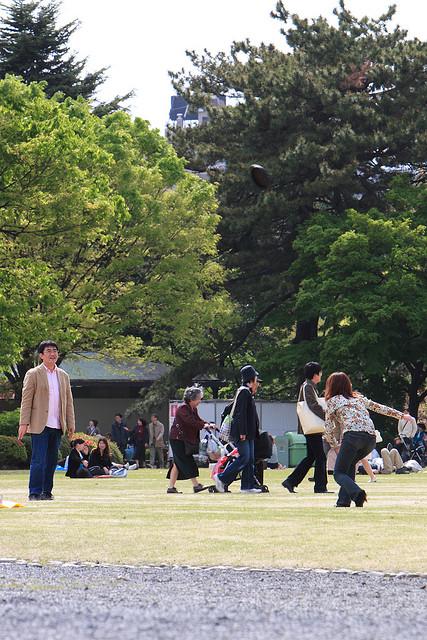Was the photo taken at night?
Write a very short answer. No. Is this a family event?
Be succinct. Yes. What color is the women on the right bag?
Quick response, please. White. 